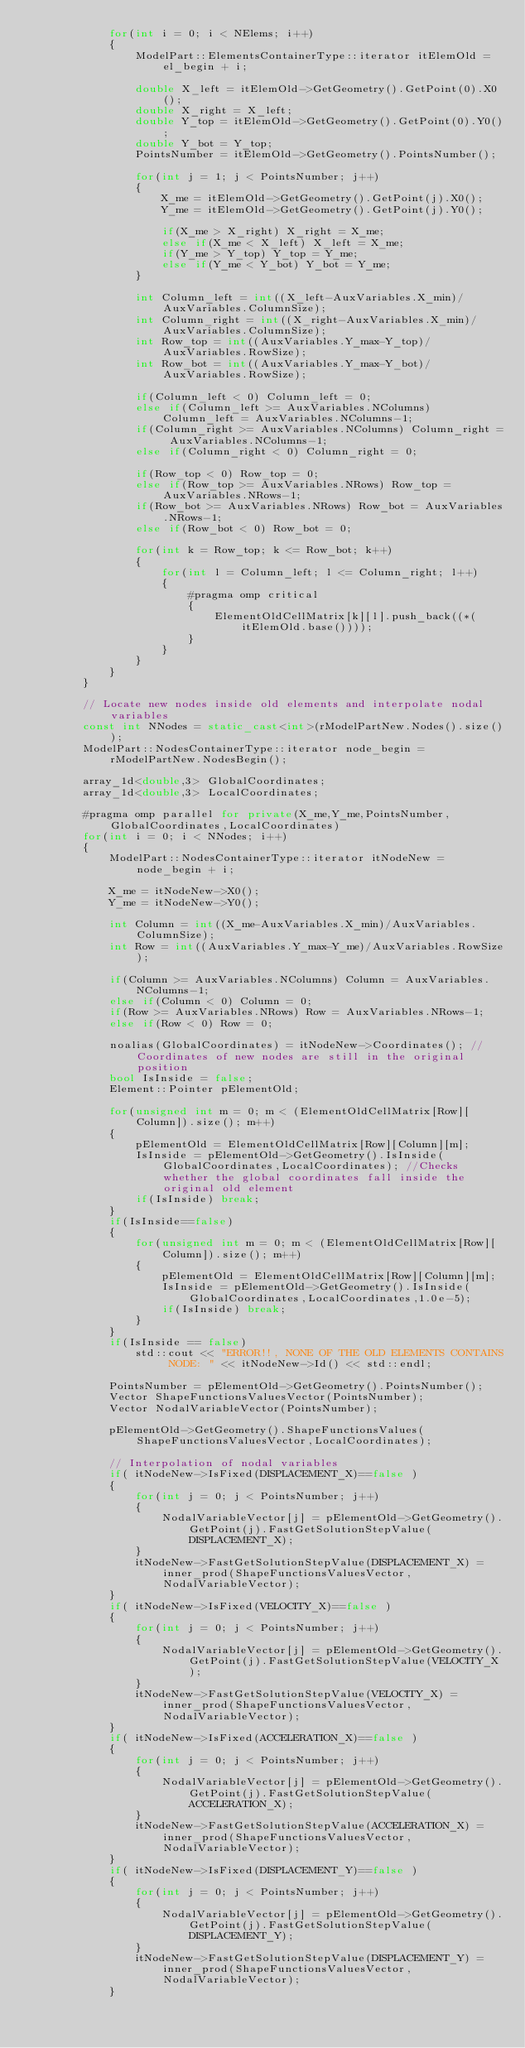<code> <loc_0><loc_0><loc_500><loc_500><_C++_>            for(int i = 0; i < NElems; i++)
            {
                ModelPart::ElementsContainerType::iterator itElemOld = el_begin + i;

                double X_left = itElemOld->GetGeometry().GetPoint(0).X0();
                double X_right = X_left;
                double Y_top = itElemOld->GetGeometry().GetPoint(0).Y0();
                double Y_bot = Y_top;
                PointsNumber = itElemOld->GetGeometry().PointsNumber();

                for(int j = 1; j < PointsNumber; j++)
                {
                    X_me = itElemOld->GetGeometry().GetPoint(j).X0();
                    Y_me = itElemOld->GetGeometry().GetPoint(j).Y0();

                    if(X_me > X_right) X_right = X_me;
                    else if(X_me < X_left) X_left = X_me;
                    if(Y_me > Y_top) Y_top = Y_me;
                    else if(Y_me < Y_bot) Y_bot = Y_me;
                }

                int Column_left = int((X_left-AuxVariables.X_min)/AuxVariables.ColumnSize);
                int Column_right = int((X_right-AuxVariables.X_min)/AuxVariables.ColumnSize);
                int Row_top = int((AuxVariables.Y_max-Y_top)/AuxVariables.RowSize);
                int Row_bot = int((AuxVariables.Y_max-Y_bot)/AuxVariables.RowSize);

                if(Column_left < 0) Column_left = 0;
                else if(Column_left >= AuxVariables.NColumns) Column_left = AuxVariables.NColumns-1;
                if(Column_right >= AuxVariables.NColumns) Column_right = AuxVariables.NColumns-1;
                else if(Column_right < 0) Column_right = 0;

                if(Row_top < 0) Row_top = 0;
                else if(Row_top >= AuxVariables.NRows) Row_top = AuxVariables.NRows-1;
                if(Row_bot >= AuxVariables.NRows) Row_bot = AuxVariables.NRows-1;
                else if(Row_bot < 0) Row_bot = 0;

                for(int k = Row_top; k <= Row_bot; k++)
                {
                    for(int l = Column_left; l <= Column_right; l++)
                    {
                        #pragma omp critical
                        {
                            ElementOldCellMatrix[k][l].push_back((*(itElemOld.base())));
                        }
                    }
                }
            }
        }

        // Locate new nodes inside old elements and interpolate nodal variables
        const int NNodes = static_cast<int>(rModelPartNew.Nodes().size());
        ModelPart::NodesContainerType::iterator node_begin = rModelPartNew.NodesBegin();

        array_1d<double,3> GlobalCoordinates;
        array_1d<double,3> LocalCoordinates;

        #pragma omp parallel for private(X_me,Y_me,PointsNumber,GlobalCoordinates,LocalCoordinates)
        for(int i = 0; i < NNodes; i++)
        {
            ModelPart::NodesContainerType::iterator itNodeNew = node_begin + i;

            X_me = itNodeNew->X0();
            Y_me = itNodeNew->Y0();

            int Column = int((X_me-AuxVariables.X_min)/AuxVariables.ColumnSize);
            int Row = int((AuxVariables.Y_max-Y_me)/AuxVariables.RowSize);

            if(Column >= AuxVariables.NColumns) Column = AuxVariables.NColumns-1;
            else if(Column < 0) Column = 0;
            if(Row >= AuxVariables.NRows) Row = AuxVariables.NRows-1;
            else if(Row < 0) Row = 0;

            noalias(GlobalCoordinates) = itNodeNew->Coordinates(); //Coordinates of new nodes are still in the original position
            bool IsInside = false;
            Element::Pointer pElementOld;

            for(unsigned int m = 0; m < (ElementOldCellMatrix[Row][Column]).size(); m++)
            {
                pElementOld = ElementOldCellMatrix[Row][Column][m];
                IsInside = pElementOld->GetGeometry().IsInside(GlobalCoordinates,LocalCoordinates); //Checks whether the global coordinates fall inside the original old element
                if(IsInside) break;
            }
            if(IsInside==false)
            {
                for(unsigned int m = 0; m < (ElementOldCellMatrix[Row][Column]).size(); m++)
                {
                    pElementOld = ElementOldCellMatrix[Row][Column][m];
                    IsInside = pElementOld->GetGeometry().IsInside(GlobalCoordinates,LocalCoordinates,1.0e-5);
                    if(IsInside) break;
                }
            }
            if(IsInside == false)
                std::cout << "ERROR!!, NONE OF THE OLD ELEMENTS CONTAINS NODE: " << itNodeNew->Id() << std::endl;

            PointsNumber = pElementOld->GetGeometry().PointsNumber();
            Vector ShapeFunctionsValuesVector(PointsNumber);
            Vector NodalVariableVector(PointsNumber);

            pElementOld->GetGeometry().ShapeFunctionsValues(ShapeFunctionsValuesVector,LocalCoordinates);

            // Interpolation of nodal variables
            if( itNodeNew->IsFixed(DISPLACEMENT_X)==false )
            {
                for(int j = 0; j < PointsNumber; j++)
                {
                    NodalVariableVector[j] = pElementOld->GetGeometry().GetPoint(j).FastGetSolutionStepValue(DISPLACEMENT_X);
                }
                itNodeNew->FastGetSolutionStepValue(DISPLACEMENT_X) = inner_prod(ShapeFunctionsValuesVector,NodalVariableVector);
            }
            if( itNodeNew->IsFixed(VELOCITY_X)==false )
            {
                for(int j = 0; j < PointsNumber; j++)
                {
                    NodalVariableVector[j] = pElementOld->GetGeometry().GetPoint(j).FastGetSolutionStepValue(VELOCITY_X);
                }
                itNodeNew->FastGetSolutionStepValue(VELOCITY_X) = inner_prod(ShapeFunctionsValuesVector,NodalVariableVector);
            }
            if( itNodeNew->IsFixed(ACCELERATION_X)==false )
            {
                for(int j = 0; j < PointsNumber; j++)
                {
                    NodalVariableVector[j] = pElementOld->GetGeometry().GetPoint(j).FastGetSolutionStepValue(ACCELERATION_X);
                }
                itNodeNew->FastGetSolutionStepValue(ACCELERATION_X) = inner_prod(ShapeFunctionsValuesVector,NodalVariableVector);
            }
            if( itNodeNew->IsFixed(DISPLACEMENT_Y)==false )
            {
                for(int j = 0; j < PointsNumber; j++)
                {
                    NodalVariableVector[j] = pElementOld->GetGeometry().GetPoint(j).FastGetSolutionStepValue(DISPLACEMENT_Y);
                }
                itNodeNew->FastGetSolutionStepValue(DISPLACEMENT_Y) = inner_prod(ShapeFunctionsValuesVector,NodalVariableVector);
            }</code> 